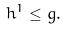<formula> <loc_0><loc_0><loc_500><loc_500>h ^ { 1 } \leq g .</formula> 